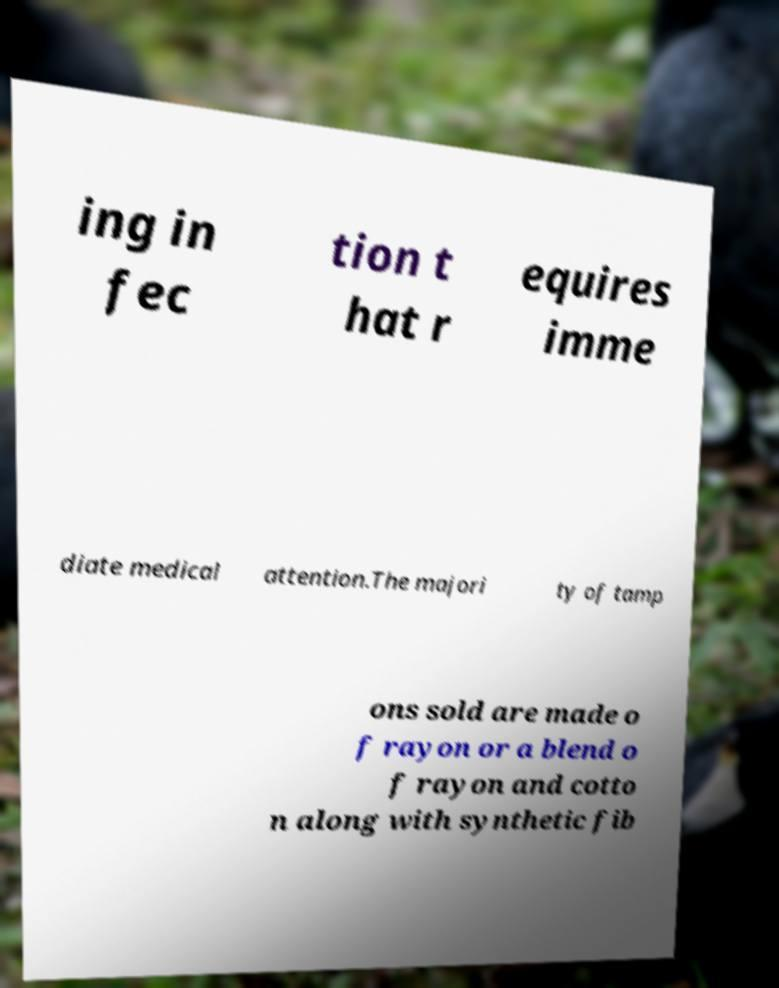Could you extract and type out the text from this image? ing in fec tion t hat r equires imme diate medical attention.The majori ty of tamp ons sold are made o f rayon or a blend o f rayon and cotto n along with synthetic fib 